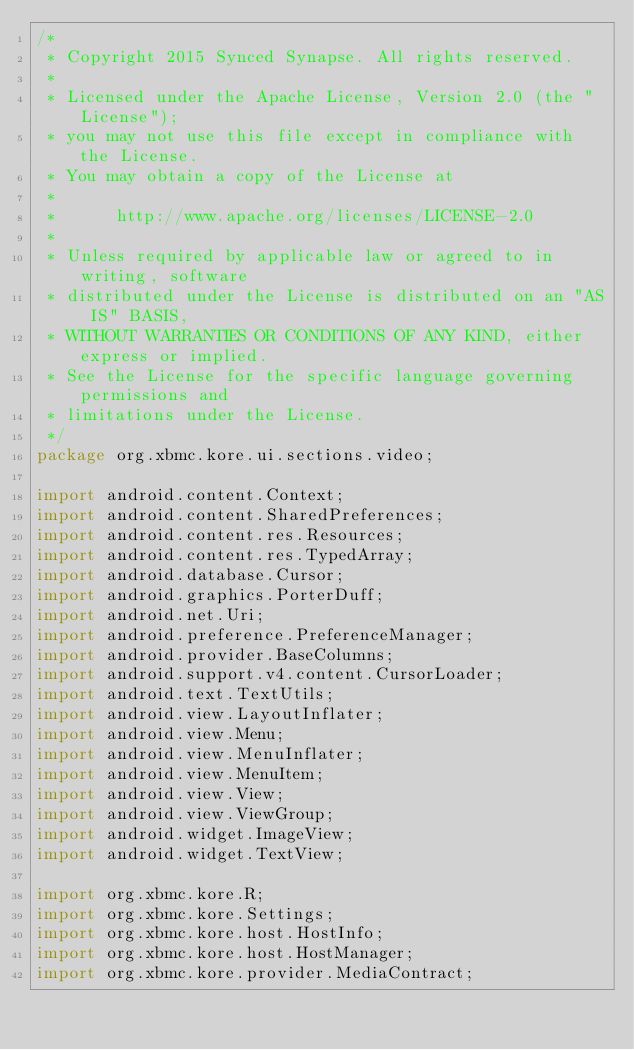Convert code to text. <code><loc_0><loc_0><loc_500><loc_500><_Java_>/*
 * Copyright 2015 Synced Synapse. All rights reserved.
 *
 * Licensed under the Apache License, Version 2.0 (the "License");
 * you may not use this file except in compliance with the License.
 * You may obtain a copy of the License at
 *
 *      http://www.apache.org/licenses/LICENSE-2.0
 *
 * Unless required by applicable law or agreed to in writing, software
 * distributed under the License is distributed on an "AS IS" BASIS,
 * WITHOUT WARRANTIES OR CONDITIONS OF ANY KIND, either express or implied.
 * See the License for the specific language governing permissions and
 * limitations under the License.
 */
package org.xbmc.kore.ui.sections.video;

import android.content.Context;
import android.content.SharedPreferences;
import android.content.res.Resources;
import android.content.res.TypedArray;
import android.database.Cursor;
import android.graphics.PorterDuff;
import android.net.Uri;
import android.preference.PreferenceManager;
import android.provider.BaseColumns;
import android.support.v4.content.CursorLoader;
import android.text.TextUtils;
import android.view.LayoutInflater;
import android.view.Menu;
import android.view.MenuInflater;
import android.view.MenuItem;
import android.view.View;
import android.view.ViewGroup;
import android.widget.ImageView;
import android.widget.TextView;

import org.xbmc.kore.R;
import org.xbmc.kore.Settings;
import org.xbmc.kore.host.HostInfo;
import org.xbmc.kore.host.HostManager;
import org.xbmc.kore.provider.MediaContract;</code> 